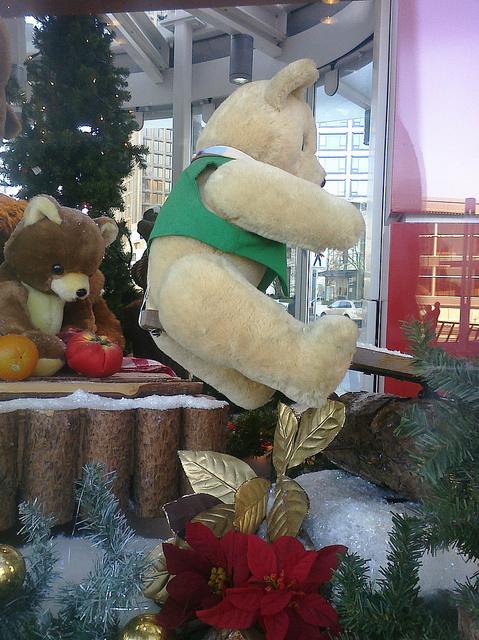What item of clothing is the bear wearing?
Answer briefly. Vest. What season is this?
Keep it brief. Winter. Is the snow real or fake?
Quick response, please. Fake. 